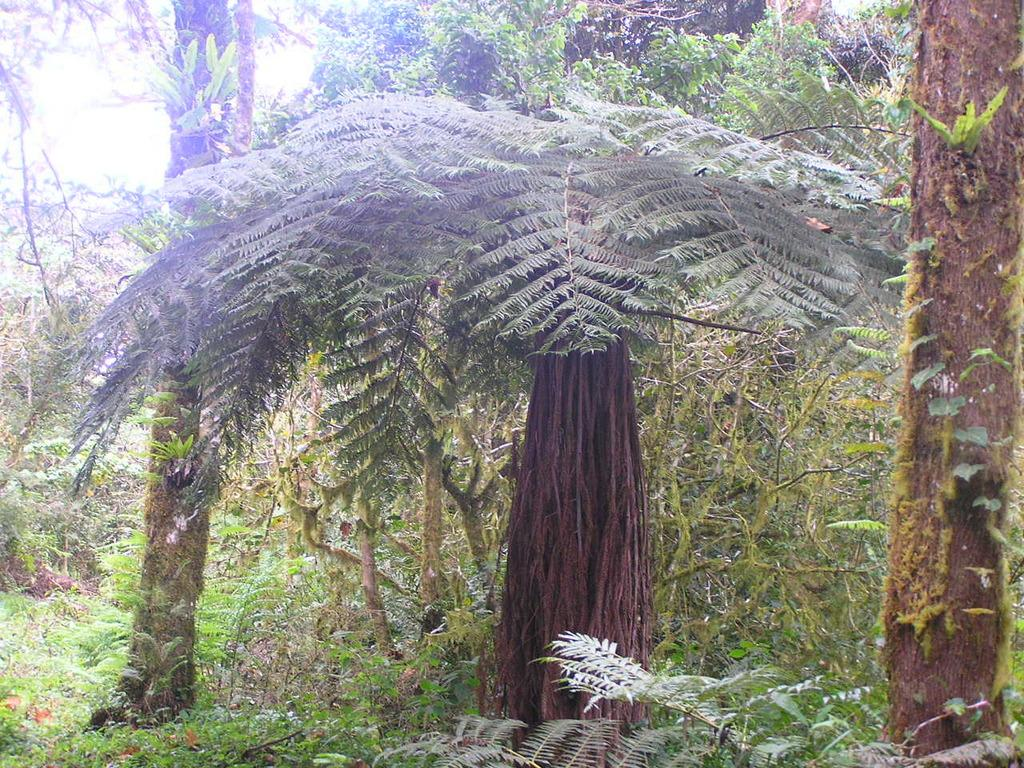What type of living organisms can be seen in the image? There are plants in the image. What color are the plants in the image? The plants are green in color. What else is visible in the image besides the plants? There is a sky visible in the image. What color is the sky in the image? The sky is white in color. Can you see any stamps on the plants in the image? There are no stamps present on the plants in the image. Are there any patches of different colors on the plants in the image? The plants in the image are described as being green, and there is no mention of any patches of different colors. 